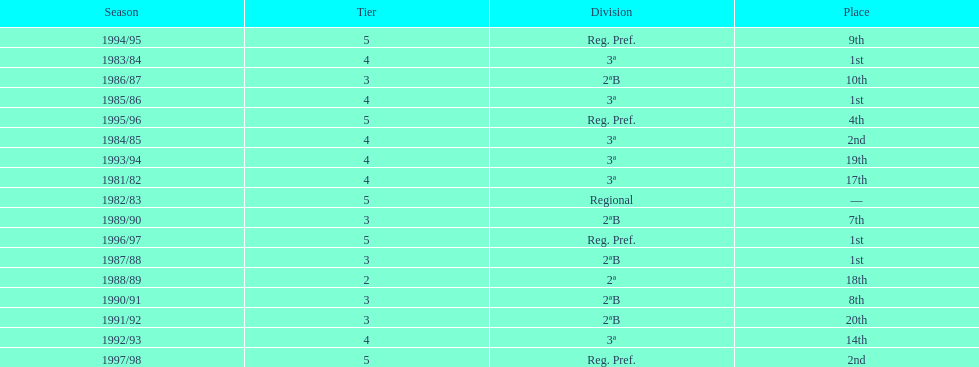In which year did the team have its worst season? 1991/92. 